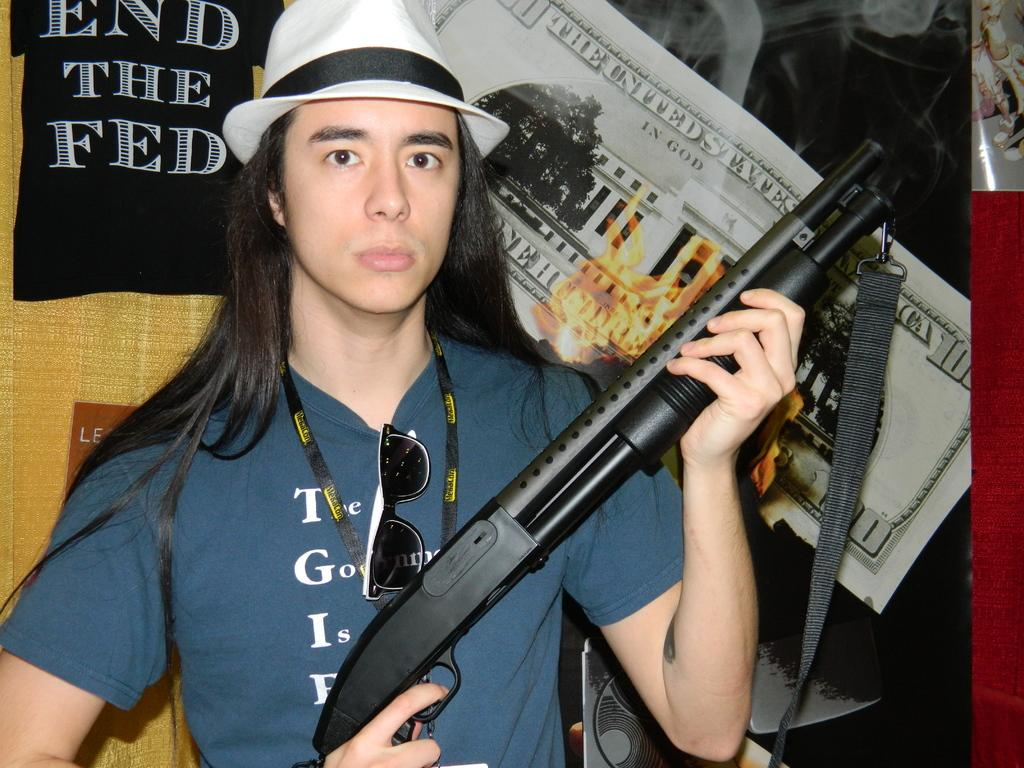Who is present in the image? There is a man in the image. What is the man holding in the image? The man is holding a black color gun. What is the man wearing on his upper body? The man is wearing a blue color t-shirt. What is the man wearing on his head? The man is wearing a white cap. What can be seen in the background of the image? There are posters in the background of the image. What type of worm can be seen crawling on the man's arm in the image? There is no worm present on the man's arm in the image. What is the man using to take notes in the image? There is no notebook or any indication of note-taking in the image. 